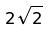<formula> <loc_0><loc_0><loc_500><loc_500>2 \sqrt { 2 }</formula> 